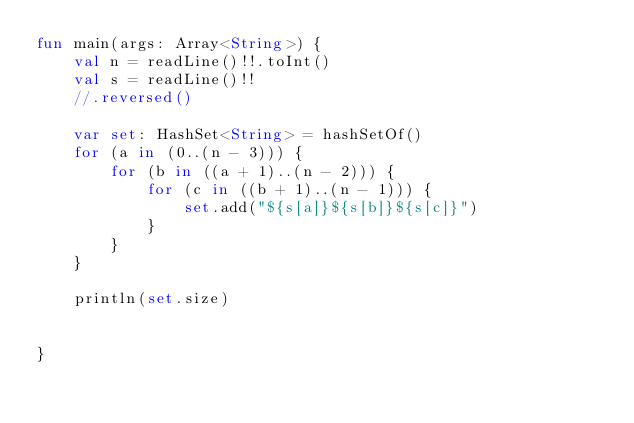Convert code to text. <code><loc_0><loc_0><loc_500><loc_500><_Kotlin_>fun main(args: Array<String>) {
    val n = readLine()!!.toInt()
    val s = readLine()!!
    //.reversed()

    var set: HashSet<String> = hashSetOf()
    for (a in (0..(n - 3))) {
        for (b in ((a + 1)..(n - 2))) {
            for (c in ((b + 1)..(n - 1))) {
                set.add("${s[a]}${s[b]}${s[c]}")
            }
        }
    }

    println(set.size)


}
</code> 